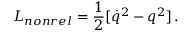Convert formula to latex. <formula><loc_0><loc_0><loc_500><loc_500>L _ { n o n r e l } = { \frac { 1 } { 2 } } [ \dot { q } ^ { 2 } - q ^ { 2 } ] \, .</formula> 